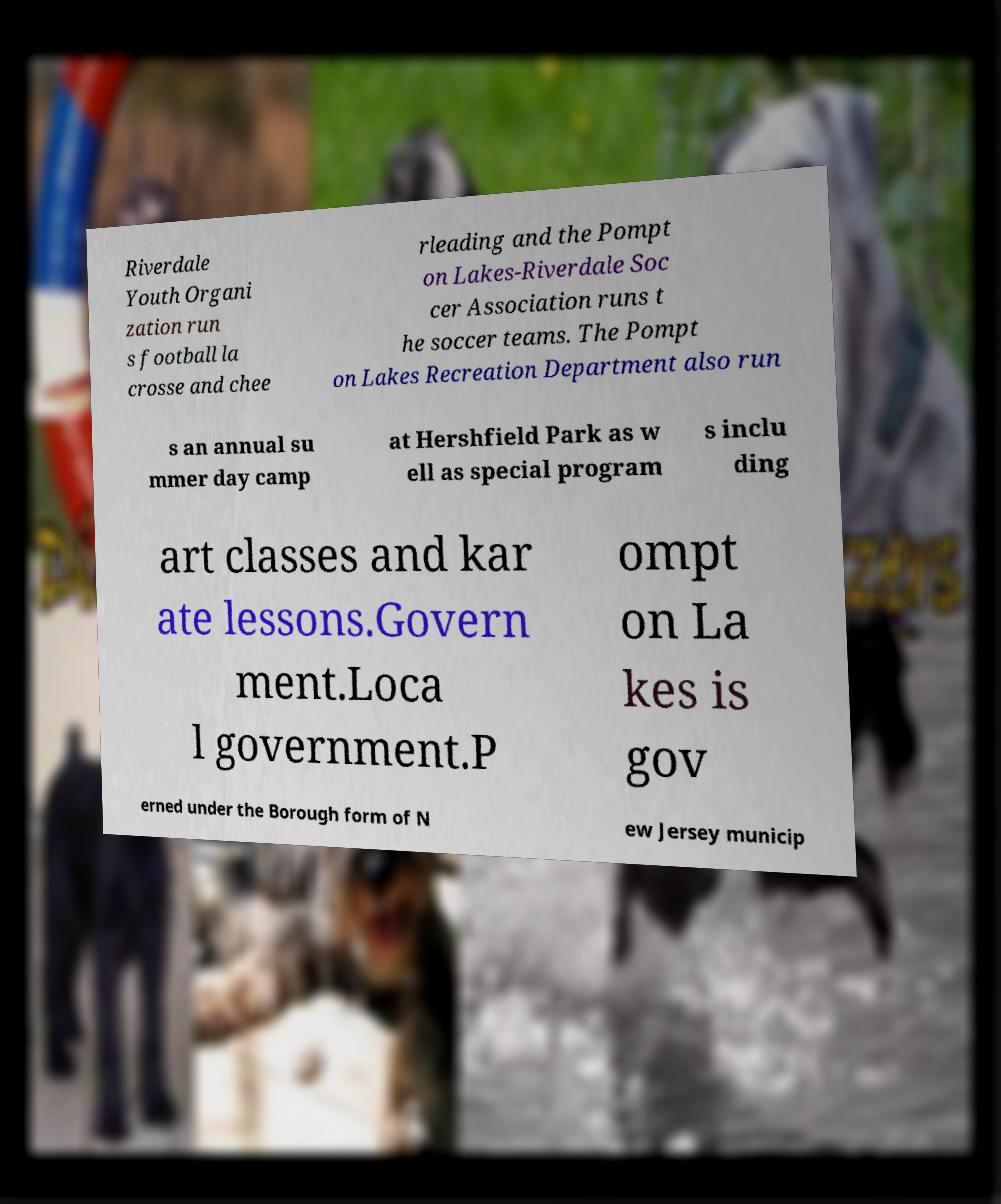Please identify and transcribe the text found in this image. Riverdale Youth Organi zation run s football la crosse and chee rleading and the Pompt on Lakes-Riverdale Soc cer Association runs t he soccer teams. The Pompt on Lakes Recreation Department also run s an annual su mmer day camp at Hershfield Park as w ell as special program s inclu ding art classes and kar ate lessons.Govern ment.Loca l government.P ompt on La kes is gov erned under the Borough form of N ew Jersey municip 